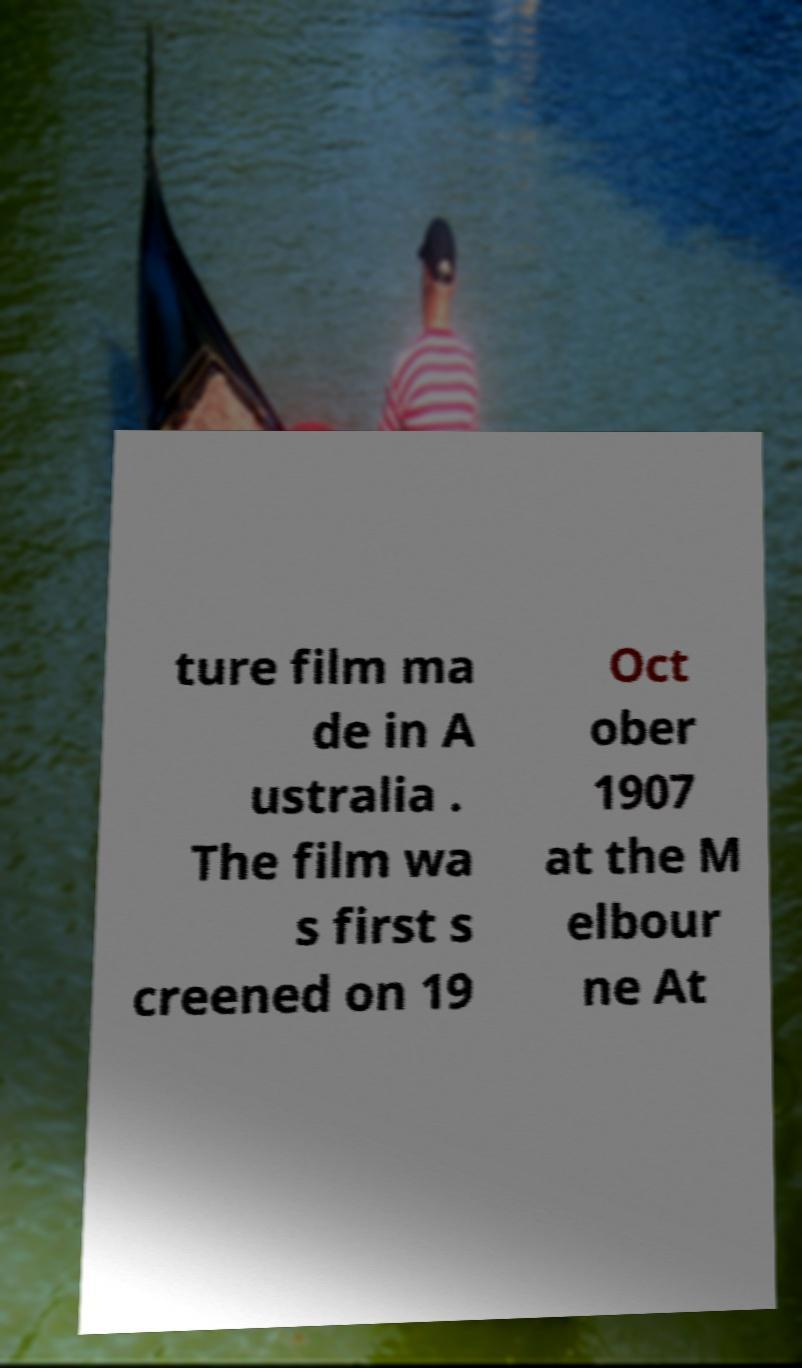What messages or text are displayed in this image? I need them in a readable, typed format. ture film ma de in A ustralia . The film wa s first s creened on 19 Oct ober 1907 at the M elbour ne At 